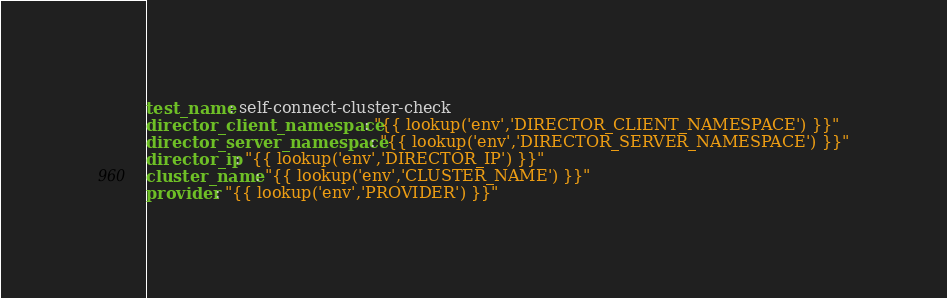Convert code to text. <code><loc_0><loc_0><loc_500><loc_500><_YAML_>test_name: self-connect-cluster-check
director_client_namespace: "{{ lookup('env','DIRECTOR_CLIENT_NAMESPACE') }}"
director_server_namespace: "{{ lookup('env','DIRECTOR_SERVER_NAMESPACE') }}"
director_ip: "{{ lookup('env','DIRECTOR_IP') }}"
cluster_name: "{{ lookup('env','CLUSTER_NAME') }}"
provider: "{{ lookup('env','PROVIDER') }}"</code> 